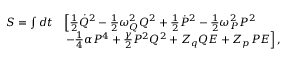<formula> <loc_0><loc_0><loc_500><loc_500>\begin{array} { r l } { S = \int d t } & { \left [ \frac { 1 } { 2 } \dot { Q } ^ { 2 } - \frac { 1 } { 2 } \omega _ { Q } ^ { 2 } Q ^ { 2 } + \frac { 1 } { 2 } \dot { P } ^ { 2 } - \frac { 1 } { 2 } \omega _ { P } ^ { 2 } P ^ { 2 } } \\ & { - \frac { 1 } { 4 } \alpha P ^ { 4 } + \frac { \gamma } { 2 } P ^ { 2 } Q ^ { 2 } + Z _ { q } Q E + Z _ { p } P E \right ] , } \end{array}</formula> 